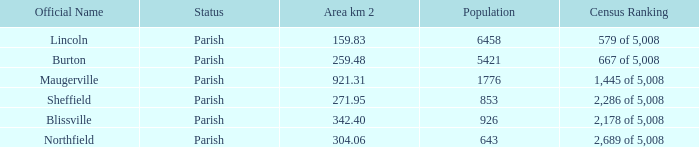Can you provide the recognized names for areas that measure 304.06 square kilometers in size? Northfield. 